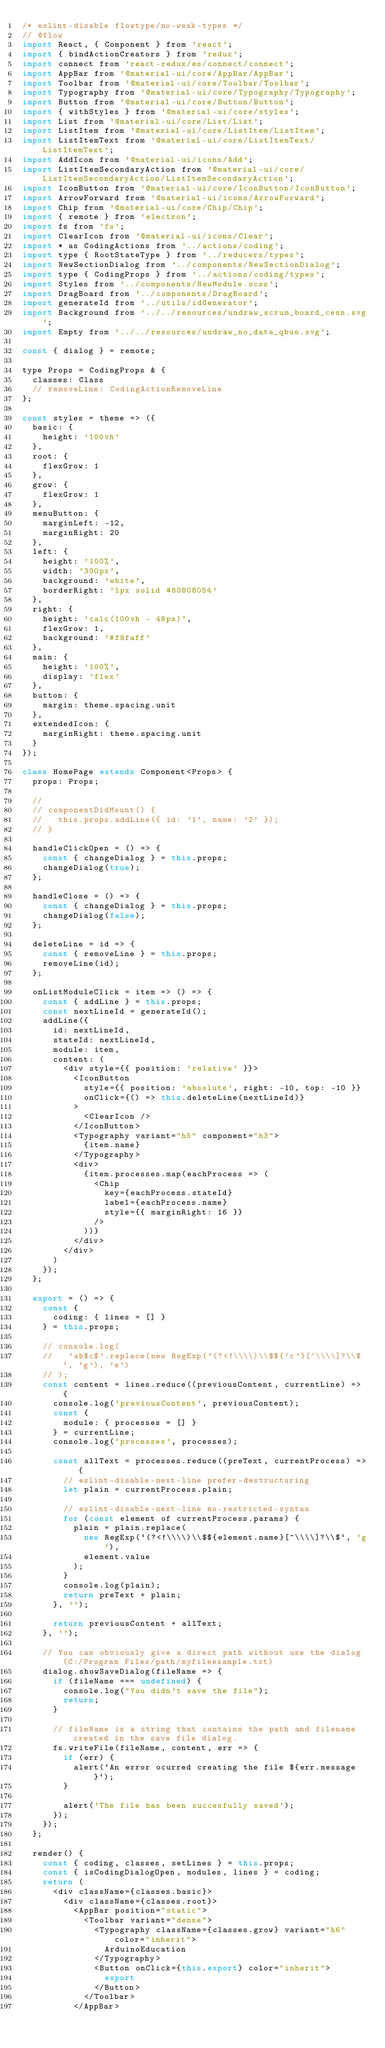<code> <loc_0><loc_0><loc_500><loc_500><_JavaScript_>/* eslint-disable flowtype/no-weak-types */
// @flow
import React, { Component } from 'react';
import { bindActionCreators } from 'redux';
import connect from 'react-redux/es/connect/connect';
import AppBar from '@material-ui/core/AppBar/AppBar';
import Toolbar from '@material-ui/core/Toolbar/Toolbar';
import Typography from '@material-ui/core/Typography/Typography';
import Button from '@material-ui/core/Button/Button';
import { withStyles } from '@material-ui/core/styles';
import List from '@material-ui/core/List/List';
import ListItem from '@material-ui/core/ListItem/ListItem';
import ListItemText from '@material-ui/core/ListItemText/ListItemText';
import AddIcon from '@material-ui/icons/Add';
import ListItemSecondaryAction from '@material-ui/core/ListItemSecondaryAction/ListItemSecondaryAction';
import IconButton from '@material-ui/core/IconButton/IconButton';
import ArrowForward from '@material-ui/icons/ArrowForward';
import Chip from '@material-ui/core/Chip/Chip';
import { remote } from 'electron';
import fs from 'fs';
import ClearIcon from '@material-ui/icons/Clear';
import * as CodingActions from '../actions/coding';
import type { RootStateType } from '../reducers/types';
import NewSectionDialog from '../components/NewSectionDialog';
import type { CodingProps } from '../actions/coding/types';
import Styles from '../components/NewModule.scss';
import DragBoard from '../components/DragBoard';
import generateId from '../utils/idGenerator';
import Background from '../../resources/undraw_scrum_board_cesn.svg';
import Empty from '../../resources/undraw_no_data_qbuo.svg';

const { dialog } = remote;

type Props = CodingProps & {
  classes: Class
  // removeLine: CodingActionRemoveLine
};

const styles = theme => ({
  basic: {
    height: '100vh'
  },
  root: {
    flexGrow: 1
  },
  grow: {
    flexGrow: 1
  },
  menuButton: {
    marginLeft: -12,
    marginRight: 20
  },
  left: {
    height: '100%',
    width: '300px',
    background: 'white',
    borderRight: '1px solid #80808054'
  },
  right: {
    height: 'calc(100vh - 48px)',
    flexGrow: 1,
    background: '#f8faff'
  },
  main: {
    height: '100%',
    display: 'flex'
  },
  button: {
    margin: theme.spacing.unit
  },
  extendedIcon: {
    marginRight: theme.spacing.unit
  }
});

class HomePage extends Component<Props> {
  props: Props;

  //
  // componentDidMount() {
  //   this.props.addLine({ id: '1', name: '2' });
  // }

  handleClickOpen = () => {
    const { changeDialog } = this.props;
    changeDialog(true);
  };

  handleClose = () => {
    const { changeDialog } = this.props;
    changeDialog(false);
  };

  deleteLine = id => {
    const { removeLine } = this.props;
    removeLine(id);
  };

  onListModuleClick = item => () => {
    const { addLine } = this.props;
    const nextLineId = generateId();
    addLine({
      id: nextLineId,
      stateId: nextLineId,
      module: item,
      content: (
        <div style={{ position: 'relative' }}>
          <IconButton
            style={{ position: 'absolute', right: -10, top: -10 }}
            onClick={() => this.deleteLine(nextLineId)}
          >
            <ClearIcon />
          </IconButton>
          <Typography variant="h5" component="h3">
            {item.name}
          </Typography>
          <div>
            {item.processes.map(eachProcess => (
              <Chip
                key={eachProcess.stateId}
                label={eachProcess.name}
                style={{ marginRight: 16 }}
              />
            ))}
          </div>
        </div>
      )
    });
  };

  export = () => {
    const {
      coding: { lines = [] }
    } = this.props;

    // console.log(
    //   'ab$c$'.replace(new RegExp(`(?<!\\\\)\\$${'c'}[^\\\\]?\\$`, 'g'), 'e')
    // );
    const content = lines.reduce((previousContent, currentLine) => {
      console.log('previousContent', previousContent);
      const {
        module: { processes = [] }
      } = currentLine;
      console.log('processes', processes);

      const allText = processes.reduce((preText, currentProcess) => {
        // eslint-disable-next-line prefer-destructuring
        let plain = currentProcess.plain;

        // eslint-disable-next-line no-restricted-syntax
        for (const element of currentProcess.params) {
          plain = plain.replace(
            new RegExp(`(?<!\\\\)\\$${element.name}[^\\\\]?\\$`, 'g'),
            element.value
          );
        }
        console.log(plain);
        return preText + plain;
      }, '');

      return previousContent + allText;
    }, '');

    // You can obviously give a direct path without use the dialog (C:/Program Files/path/myfileexample.txt)
    dialog.showSaveDialog(fileName => {
      if (fileName === undefined) {
        console.log("You didn't save the file");
        return;
      }

      // fileName is a string that contains the path and filename created in the save file dialog.
      fs.writeFile(fileName, content, err => {
        if (err) {
          alert(`An error ocurred creating the file ${err.message}`);
        }

        alert('The file has been succesfully saved');
      });
    });
  };

  render() {
    const { coding, classes, setLines } = this.props;
    const { isCodingDialogOpen, modules, lines } = coding;
    return (
      <div className={classes.basic}>
        <div className={classes.root}>
          <AppBar position="static">
            <Toolbar variant="dense">
              <Typography className={classes.grow} variant="h6" color="inherit">
                ArduinoEducation
              </Typography>
              <Button onClick={this.export} color="inherit">
                export
              </Button>
            </Toolbar>
          </AppBar></code> 